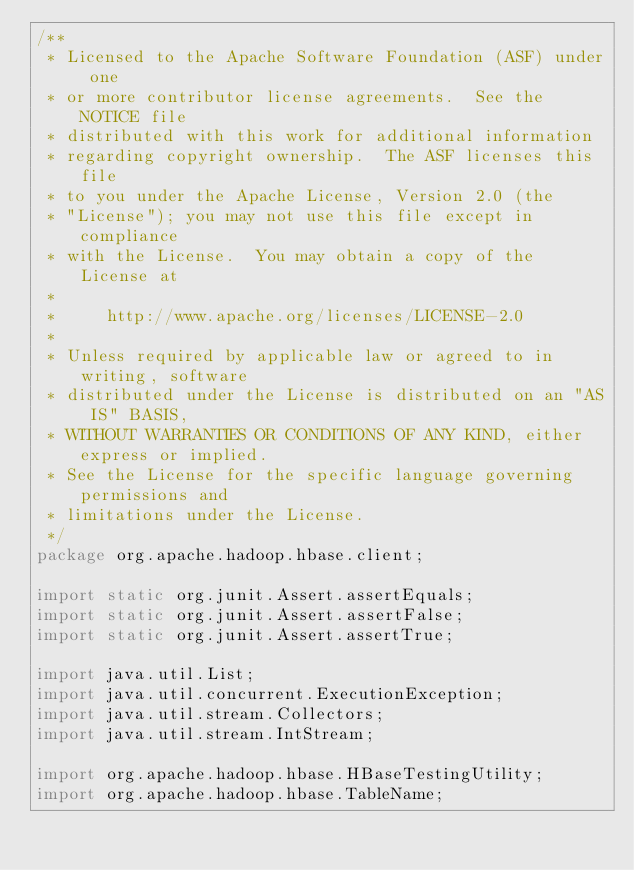Convert code to text. <code><loc_0><loc_0><loc_500><loc_500><_Java_>/**
 * Licensed to the Apache Software Foundation (ASF) under one
 * or more contributor license agreements.  See the NOTICE file
 * distributed with this work for additional information
 * regarding copyright ownership.  The ASF licenses this file
 * to you under the Apache License, Version 2.0 (the
 * "License"); you may not use this file except in compliance
 * with the License.  You may obtain a copy of the License at
 *
 *     http://www.apache.org/licenses/LICENSE-2.0
 *
 * Unless required by applicable law or agreed to in writing, software
 * distributed under the License is distributed on an "AS IS" BASIS,
 * WITHOUT WARRANTIES OR CONDITIONS OF ANY KIND, either express or implied.
 * See the License for the specific language governing permissions and
 * limitations under the License.
 */
package org.apache.hadoop.hbase.client;

import static org.junit.Assert.assertEquals;
import static org.junit.Assert.assertFalse;
import static org.junit.Assert.assertTrue;

import java.util.List;
import java.util.concurrent.ExecutionException;
import java.util.stream.Collectors;
import java.util.stream.IntStream;

import org.apache.hadoop.hbase.HBaseTestingUtility;
import org.apache.hadoop.hbase.TableName;</code> 